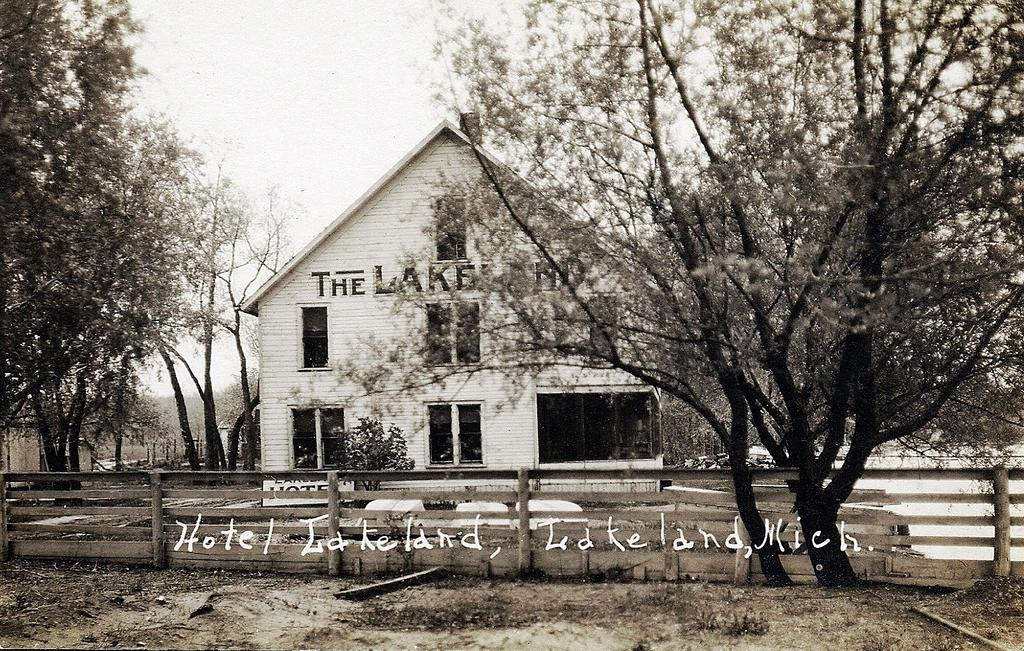<image>
Create a compact narrative representing the image presented. a portrait of old hotel lakeland in black and white 